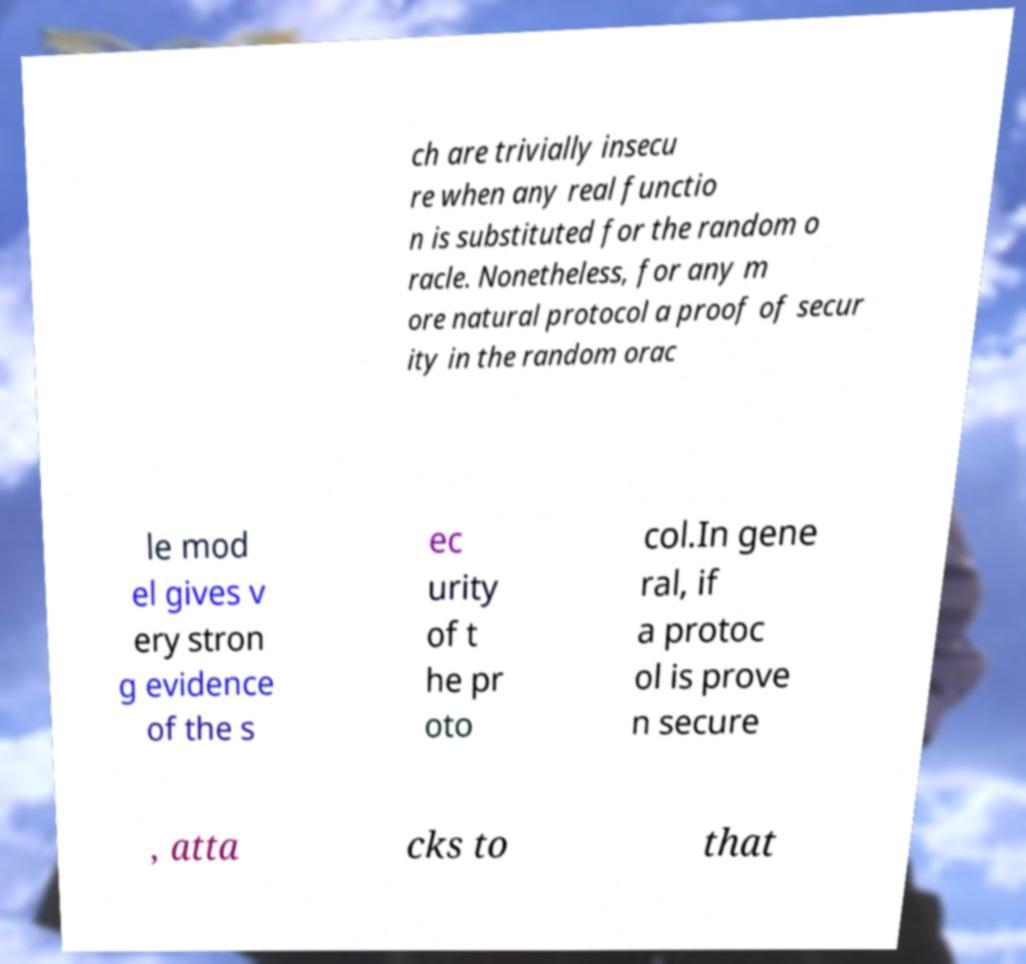Can you read and provide the text displayed in the image?This photo seems to have some interesting text. Can you extract and type it out for me? ch are trivially insecu re when any real functio n is substituted for the random o racle. Nonetheless, for any m ore natural protocol a proof of secur ity in the random orac le mod el gives v ery stron g evidence of the s ec urity of t he pr oto col.In gene ral, if a protoc ol is prove n secure , atta cks to that 